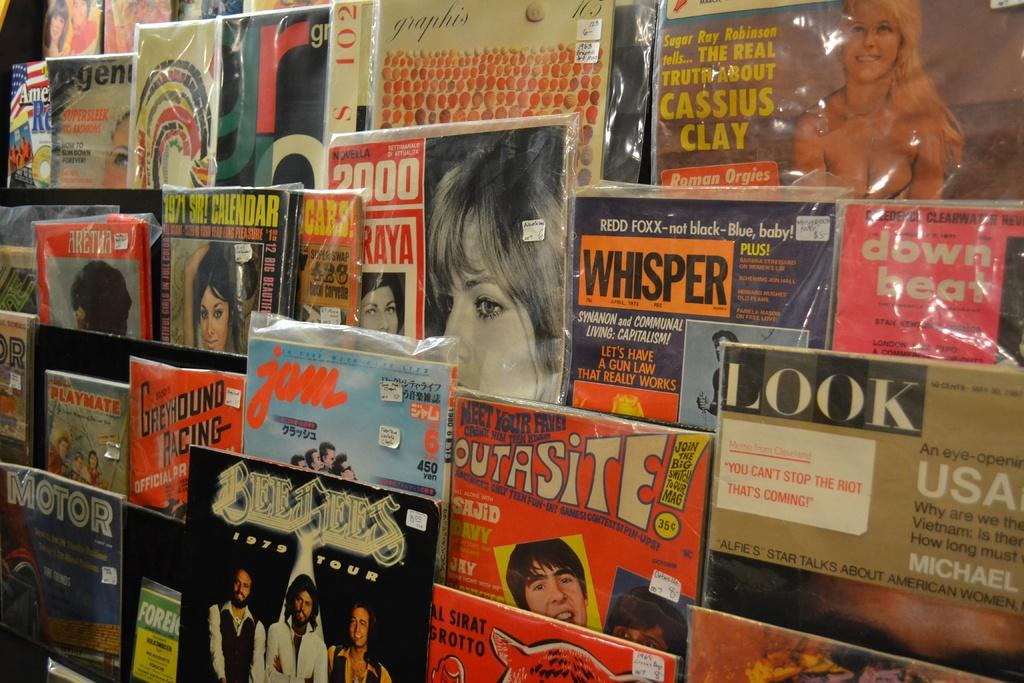<image>
Create a compact narrative representing the image presented. Several kinds of magazines are displayed together including Whisper and Look. 